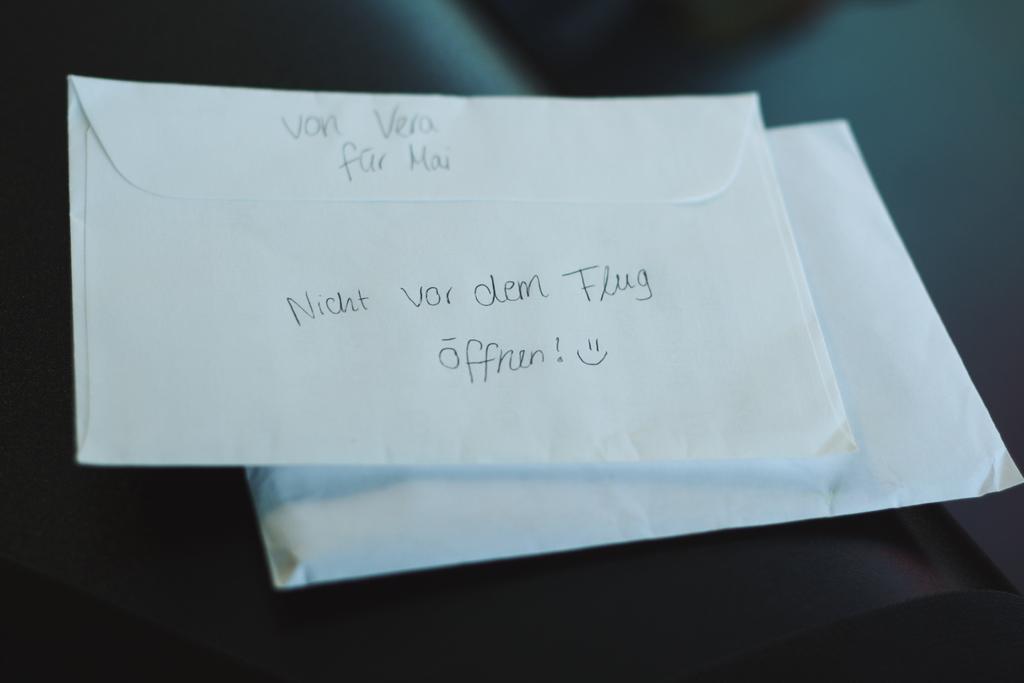What is written on the back of the envelope?
Provide a succinct answer. Nicht vor dem flug. What is written on the envelope?
Provide a short and direct response. Von vera fur mai - nicht vor dem flug offnen! . 